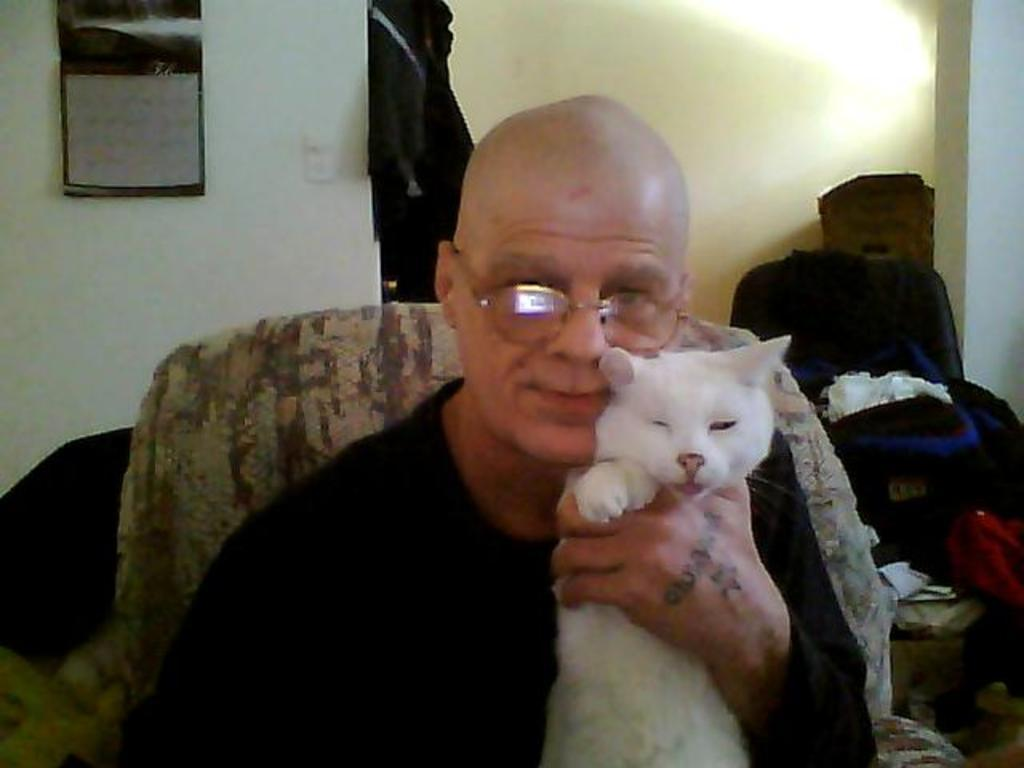What is the main subject of the image? The main subject of the image is a man. What is the man doing in the image? The man is seated on a chair in the image. Is there anything else in the man's hand besides the chair? Yes, the man is holding a cat in his hand. What type of behavior does the man exhibit towards his manager in the image? There is no manager present in the image, so it is not possible to determine the man's behavior towards a manager. 